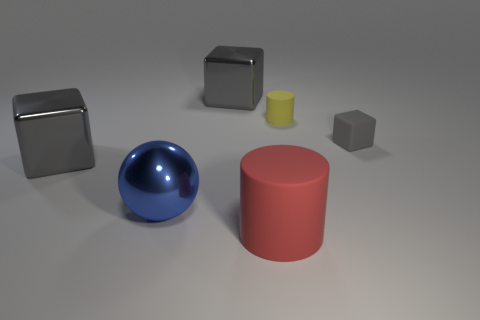Add 1 big shiny blocks. How many objects exist? 7 Subtract all balls. How many objects are left? 5 Subtract 0 red cubes. How many objects are left? 6 Subtract all small red shiny cylinders. Subtract all small gray matte objects. How many objects are left? 5 Add 3 shiny things. How many shiny things are left? 6 Add 1 yellow matte things. How many yellow matte things exist? 2 